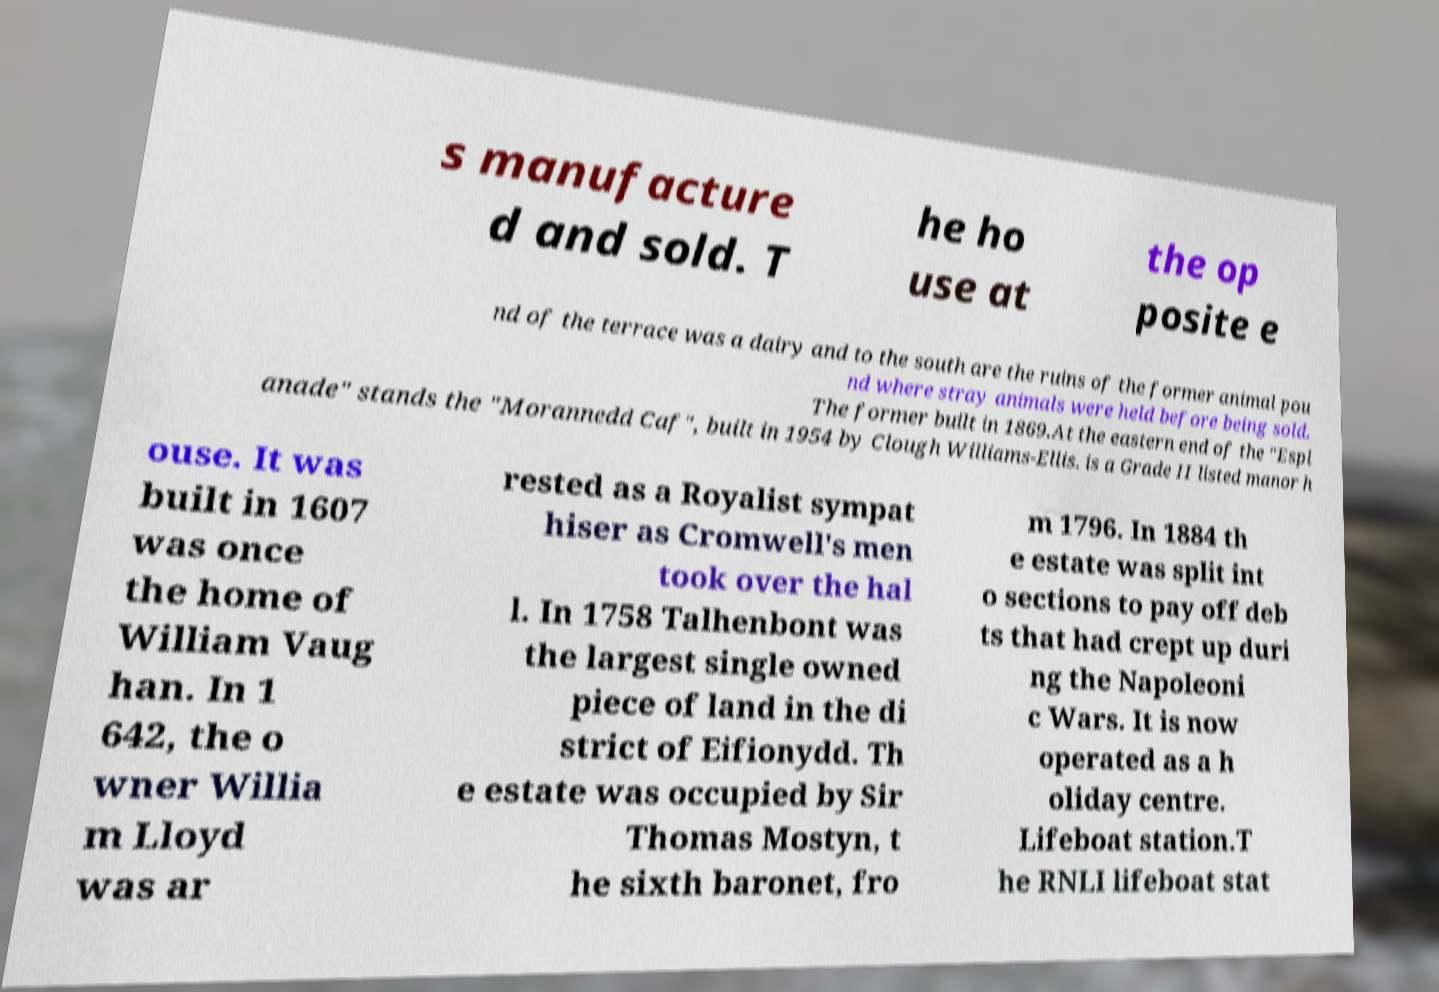Please read and relay the text visible in this image. What does it say? s manufacture d and sold. T he ho use at the op posite e nd of the terrace was a dairy and to the south are the ruins of the former animal pou nd where stray animals were held before being sold. The former built in 1869.At the eastern end of the "Espl anade" stands the "Morannedd Caf", built in 1954 by Clough Williams-Ellis. is a Grade II listed manor h ouse. It was built in 1607 was once the home of William Vaug han. In 1 642, the o wner Willia m Lloyd was ar rested as a Royalist sympat hiser as Cromwell's men took over the hal l. In 1758 Talhenbont was the largest single owned piece of land in the di strict of Eifionydd. Th e estate was occupied by Sir Thomas Mostyn, t he sixth baronet, fro m 1796. In 1884 th e estate was split int o sections to pay off deb ts that had crept up duri ng the Napoleoni c Wars. It is now operated as a h oliday centre. Lifeboat station.T he RNLI lifeboat stat 